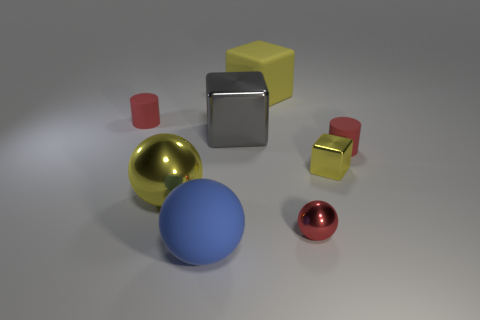There is a red rubber cylinder that is on the right side of the tiny red matte thing that is left of the small yellow shiny block; is there a red matte cylinder that is left of it?
Your answer should be compact. Yes. There is a large yellow ball; what number of red matte things are right of it?
Provide a short and direct response. 1. There is a big object that is the same color as the large metal ball; what is its material?
Your answer should be very brief. Rubber. How many small things are metal cylinders or blue balls?
Provide a succinct answer. 0. There is a large matte thing behind the blue rubber object; what is its shape?
Your answer should be very brief. Cube. Are there any balls that have the same color as the small cube?
Your response must be concise. Yes. Is the size of the matte object to the left of the big yellow sphere the same as the shiny ball to the left of the matte ball?
Provide a succinct answer. No. Are there more yellow things to the left of the tiny sphere than metallic objects that are in front of the blue thing?
Provide a succinct answer. Yes. Are there any large yellow cubes that have the same material as the red sphere?
Keep it short and to the point. No. Do the big metal sphere and the matte block have the same color?
Your answer should be very brief. Yes. 